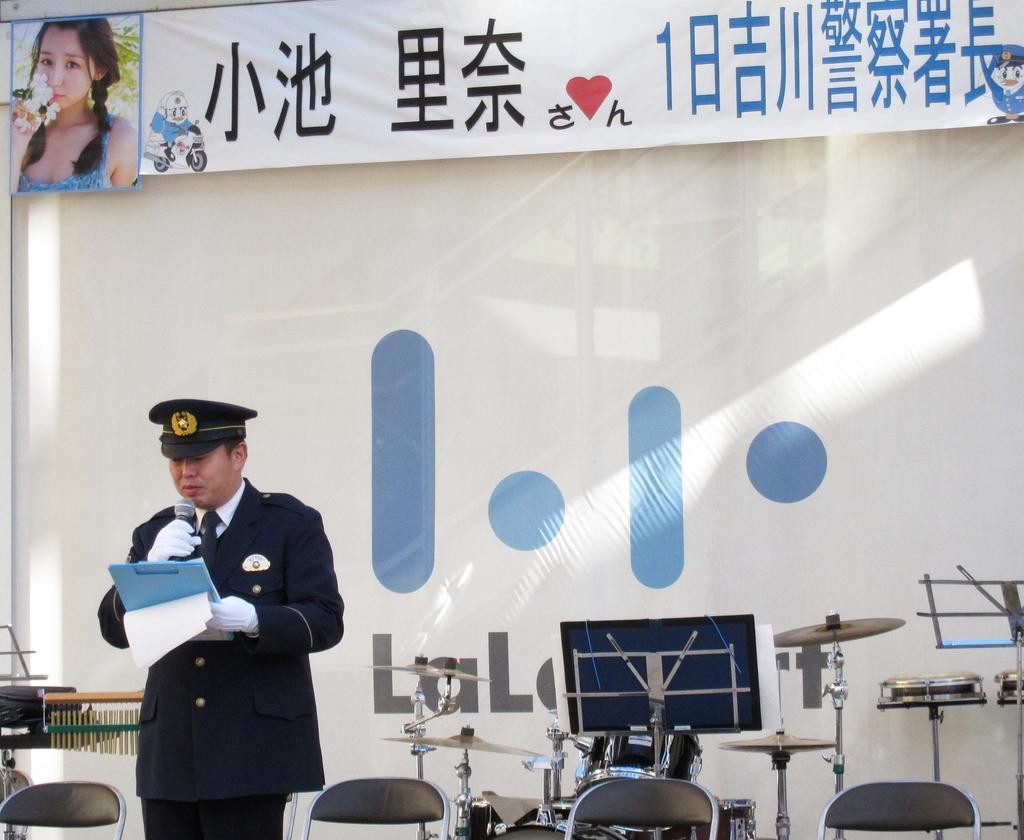How would you summarize this image in a sentence or two? In the picture I can see a man is standing and holding a microphone and some other objects in hands. The man is wearing a hat and a uniform. I can also see musical instruments, chairs, a banner which has a photo of a woman and something written on it. 